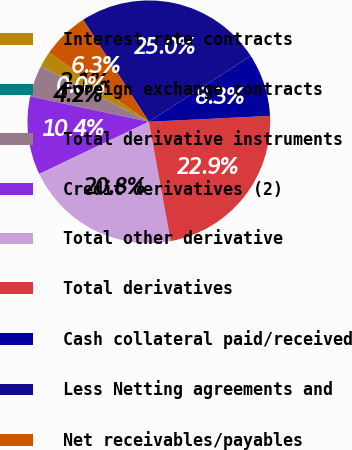<chart> <loc_0><loc_0><loc_500><loc_500><pie_chart><fcel>Interest rate contracts<fcel>Foreign exchange contracts<fcel>Total derivative instruments<fcel>Credit derivatives (2)<fcel>Total other derivative<fcel>Total derivatives<fcel>Cash collateral paid/received<fcel>Less Netting agreements and<fcel>Net receivables/payables<nl><fcel>2.1%<fcel>0.01%<fcel>4.18%<fcel>10.43%<fcel>20.81%<fcel>22.89%<fcel>8.35%<fcel>24.98%<fcel>6.26%<nl></chart> 